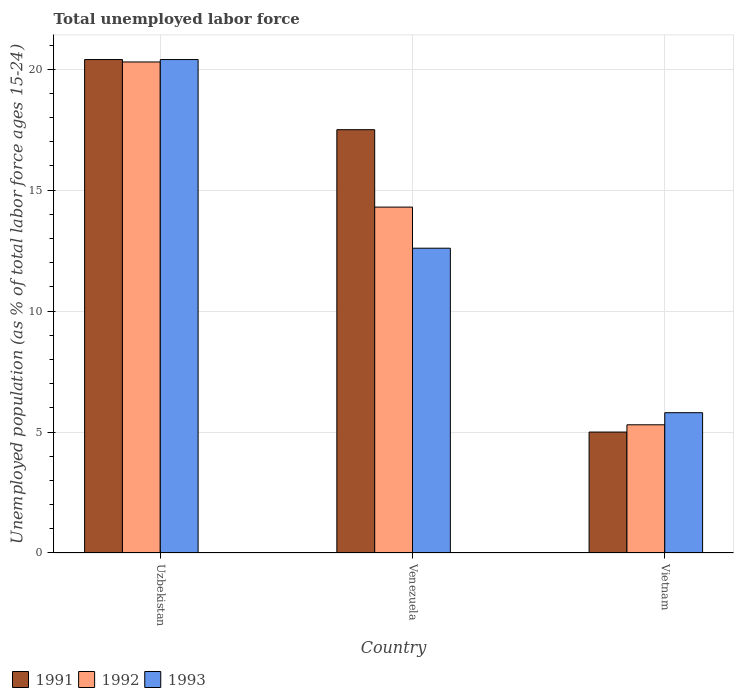How many groups of bars are there?
Ensure brevity in your answer.  3. Are the number of bars on each tick of the X-axis equal?
Your response must be concise. Yes. How many bars are there on the 1st tick from the left?
Your answer should be very brief. 3. What is the label of the 1st group of bars from the left?
Make the answer very short. Uzbekistan. What is the percentage of unemployed population in in 1991 in Uzbekistan?
Give a very brief answer. 20.4. Across all countries, what is the maximum percentage of unemployed population in in 1993?
Your answer should be compact. 20.4. Across all countries, what is the minimum percentage of unemployed population in in 1991?
Provide a succinct answer. 5. In which country was the percentage of unemployed population in in 1992 maximum?
Offer a very short reply. Uzbekistan. In which country was the percentage of unemployed population in in 1993 minimum?
Ensure brevity in your answer.  Vietnam. What is the total percentage of unemployed population in in 1991 in the graph?
Your response must be concise. 42.9. What is the difference between the percentage of unemployed population in in 1991 in Uzbekistan and that in Venezuela?
Provide a succinct answer. 2.9. What is the difference between the percentage of unemployed population in in 1993 in Vietnam and the percentage of unemployed population in in 1991 in Uzbekistan?
Give a very brief answer. -14.6. What is the average percentage of unemployed population in in 1991 per country?
Ensure brevity in your answer.  14.3. What is the difference between the percentage of unemployed population in of/in 1991 and percentage of unemployed population in of/in 1992 in Vietnam?
Your answer should be compact. -0.3. What is the ratio of the percentage of unemployed population in in 1991 in Venezuela to that in Vietnam?
Offer a very short reply. 3.5. Is the percentage of unemployed population in in 1991 in Venezuela less than that in Vietnam?
Make the answer very short. No. What is the difference between the highest and the second highest percentage of unemployed population in in 1991?
Your answer should be very brief. -2.9. What is the difference between the highest and the lowest percentage of unemployed population in in 1993?
Offer a very short reply. 14.6. In how many countries, is the percentage of unemployed population in in 1993 greater than the average percentage of unemployed population in in 1993 taken over all countries?
Ensure brevity in your answer.  1. Is the sum of the percentage of unemployed population in in 1991 in Venezuela and Vietnam greater than the maximum percentage of unemployed population in in 1993 across all countries?
Your response must be concise. Yes. Are all the bars in the graph horizontal?
Your answer should be compact. No. How many countries are there in the graph?
Make the answer very short. 3. Are the values on the major ticks of Y-axis written in scientific E-notation?
Your response must be concise. No. Does the graph contain grids?
Offer a very short reply. Yes. How many legend labels are there?
Provide a short and direct response. 3. How are the legend labels stacked?
Provide a short and direct response. Horizontal. What is the title of the graph?
Your response must be concise. Total unemployed labor force. What is the label or title of the Y-axis?
Offer a terse response. Unemployed population (as % of total labor force ages 15-24). What is the Unemployed population (as % of total labor force ages 15-24) in 1991 in Uzbekistan?
Provide a succinct answer. 20.4. What is the Unemployed population (as % of total labor force ages 15-24) of 1992 in Uzbekistan?
Your response must be concise. 20.3. What is the Unemployed population (as % of total labor force ages 15-24) of 1993 in Uzbekistan?
Make the answer very short. 20.4. What is the Unemployed population (as % of total labor force ages 15-24) in 1992 in Venezuela?
Provide a succinct answer. 14.3. What is the Unemployed population (as % of total labor force ages 15-24) in 1993 in Venezuela?
Give a very brief answer. 12.6. What is the Unemployed population (as % of total labor force ages 15-24) in 1991 in Vietnam?
Your answer should be very brief. 5. What is the Unemployed population (as % of total labor force ages 15-24) of 1992 in Vietnam?
Offer a very short reply. 5.3. What is the Unemployed population (as % of total labor force ages 15-24) in 1993 in Vietnam?
Your answer should be compact. 5.8. Across all countries, what is the maximum Unemployed population (as % of total labor force ages 15-24) in 1991?
Your response must be concise. 20.4. Across all countries, what is the maximum Unemployed population (as % of total labor force ages 15-24) in 1992?
Give a very brief answer. 20.3. Across all countries, what is the maximum Unemployed population (as % of total labor force ages 15-24) of 1993?
Keep it short and to the point. 20.4. Across all countries, what is the minimum Unemployed population (as % of total labor force ages 15-24) of 1992?
Provide a short and direct response. 5.3. Across all countries, what is the minimum Unemployed population (as % of total labor force ages 15-24) in 1993?
Give a very brief answer. 5.8. What is the total Unemployed population (as % of total labor force ages 15-24) in 1991 in the graph?
Your response must be concise. 42.9. What is the total Unemployed population (as % of total labor force ages 15-24) of 1992 in the graph?
Ensure brevity in your answer.  39.9. What is the total Unemployed population (as % of total labor force ages 15-24) of 1993 in the graph?
Offer a very short reply. 38.8. What is the difference between the Unemployed population (as % of total labor force ages 15-24) in 1993 in Uzbekistan and that in Venezuela?
Your answer should be very brief. 7.8. What is the difference between the Unemployed population (as % of total labor force ages 15-24) of 1991 in Uzbekistan and that in Vietnam?
Offer a very short reply. 15.4. What is the difference between the Unemployed population (as % of total labor force ages 15-24) of 1993 in Uzbekistan and that in Vietnam?
Provide a succinct answer. 14.6. What is the difference between the Unemployed population (as % of total labor force ages 15-24) of 1993 in Venezuela and that in Vietnam?
Give a very brief answer. 6.8. What is the difference between the Unemployed population (as % of total labor force ages 15-24) in 1992 in Uzbekistan and the Unemployed population (as % of total labor force ages 15-24) in 1993 in Venezuela?
Provide a succinct answer. 7.7. What is the difference between the Unemployed population (as % of total labor force ages 15-24) of 1991 in Uzbekistan and the Unemployed population (as % of total labor force ages 15-24) of 1993 in Vietnam?
Keep it short and to the point. 14.6. What is the difference between the Unemployed population (as % of total labor force ages 15-24) of 1991 in Venezuela and the Unemployed population (as % of total labor force ages 15-24) of 1992 in Vietnam?
Make the answer very short. 12.2. What is the difference between the Unemployed population (as % of total labor force ages 15-24) of 1991 in Venezuela and the Unemployed population (as % of total labor force ages 15-24) of 1993 in Vietnam?
Keep it short and to the point. 11.7. What is the average Unemployed population (as % of total labor force ages 15-24) of 1991 per country?
Your answer should be very brief. 14.3. What is the average Unemployed population (as % of total labor force ages 15-24) in 1992 per country?
Provide a short and direct response. 13.3. What is the average Unemployed population (as % of total labor force ages 15-24) of 1993 per country?
Ensure brevity in your answer.  12.93. What is the difference between the Unemployed population (as % of total labor force ages 15-24) of 1991 and Unemployed population (as % of total labor force ages 15-24) of 1992 in Uzbekistan?
Make the answer very short. 0.1. What is the difference between the Unemployed population (as % of total labor force ages 15-24) in 1991 and Unemployed population (as % of total labor force ages 15-24) in 1993 in Uzbekistan?
Make the answer very short. 0. What is the difference between the Unemployed population (as % of total labor force ages 15-24) of 1992 and Unemployed population (as % of total labor force ages 15-24) of 1993 in Uzbekistan?
Provide a succinct answer. -0.1. What is the difference between the Unemployed population (as % of total labor force ages 15-24) in 1992 and Unemployed population (as % of total labor force ages 15-24) in 1993 in Venezuela?
Your response must be concise. 1.7. What is the difference between the Unemployed population (as % of total labor force ages 15-24) in 1991 and Unemployed population (as % of total labor force ages 15-24) in 1992 in Vietnam?
Provide a succinct answer. -0.3. What is the difference between the Unemployed population (as % of total labor force ages 15-24) in 1991 and Unemployed population (as % of total labor force ages 15-24) in 1993 in Vietnam?
Make the answer very short. -0.8. What is the difference between the Unemployed population (as % of total labor force ages 15-24) in 1992 and Unemployed population (as % of total labor force ages 15-24) in 1993 in Vietnam?
Keep it short and to the point. -0.5. What is the ratio of the Unemployed population (as % of total labor force ages 15-24) of 1991 in Uzbekistan to that in Venezuela?
Your answer should be very brief. 1.17. What is the ratio of the Unemployed population (as % of total labor force ages 15-24) in 1992 in Uzbekistan to that in Venezuela?
Provide a succinct answer. 1.42. What is the ratio of the Unemployed population (as % of total labor force ages 15-24) of 1993 in Uzbekistan to that in Venezuela?
Offer a terse response. 1.62. What is the ratio of the Unemployed population (as % of total labor force ages 15-24) of 1991 in Uzbekistan to that in Vietnam?
Your answer should be compact. 4.08. What is the ratio of the Unemployed population (as % of total labor force ages 15-24) of 1992 in Uzbekistan to that in Vietnam?
Your answer should be very brief. 3.83. What is the ratio of the Unemployed population (as % of total labor force ages 15-24) of 1993 in Uzbekistan to that in Vietnam?
Your response must be concise. 3.52. What is the ratio of the Unemployed population (as % of total labor force ages 15-24) in 1992 in Venezuela to that in Vietnam?
Offer a very short reply. 2.7. What is the ratio of the Unemployed population (as % of total labor force ages 15-24) of 1993 in Venezuela to that in Vietnam?
Make the answer very short. 2.17. What is the difference between the highest and the second highest Unemployed population (as % of total labor force ages 15-24) in 1991?
Provide a succinct answer. 2.9. What is the difference between the highest and the second highest Unemployed population (as % of total labor force ages 15-24) of 1992?
Give a very brief answer. 6. What is the difference between the highest and the second highest Unemployed population (as % of total labor force ages 15-24) of 1993?
Your answer should be compact. 7.8. 